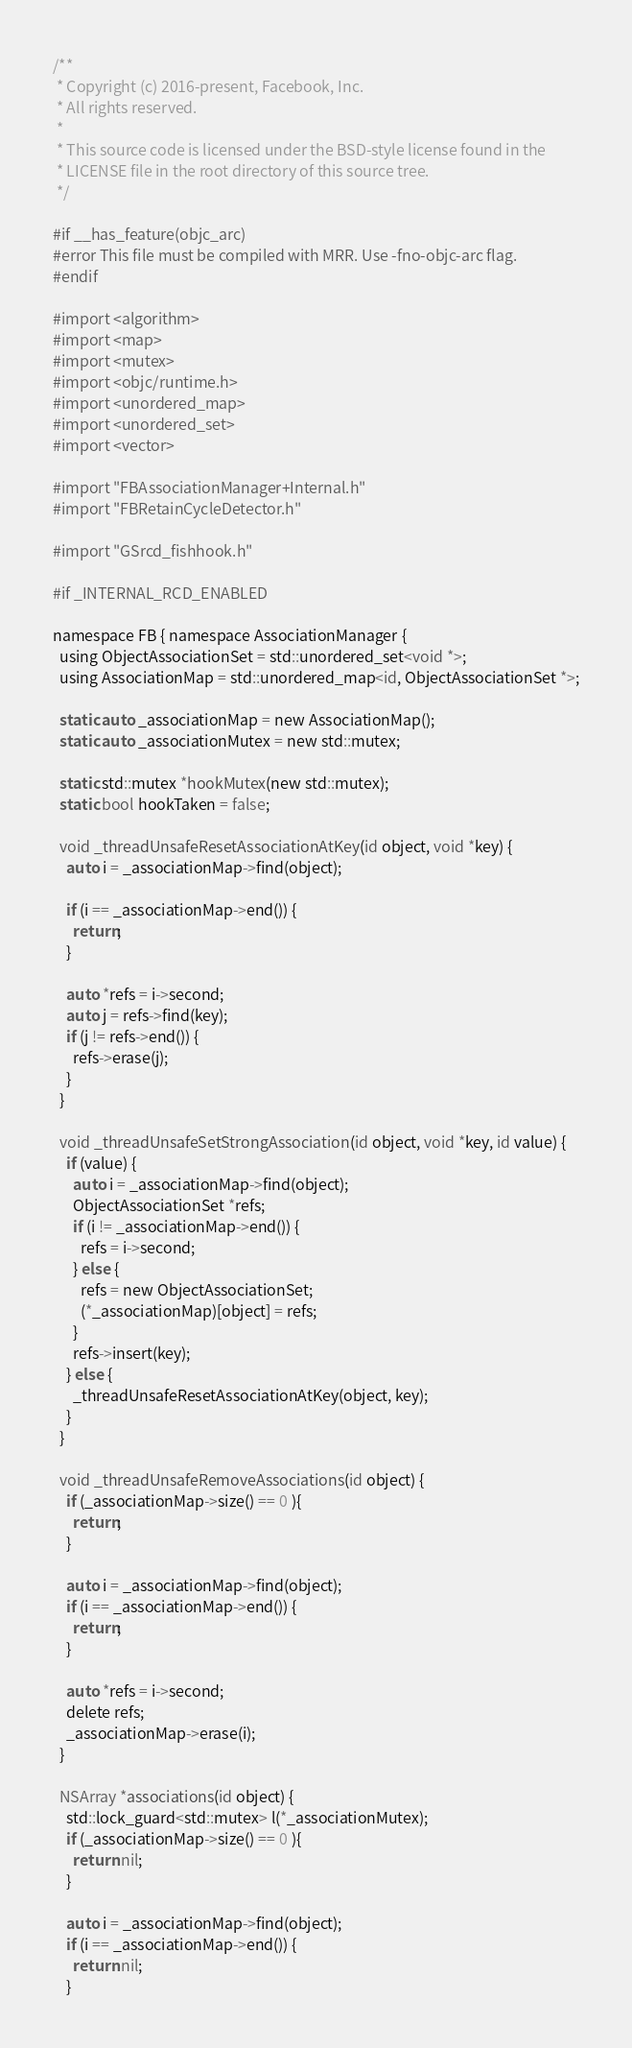<code> <loc_0><loc_0><loc_500><loc_500><_ObjectiveC_>/**
 * Copyright (c) 2016-present, Facebook, Inc.
 * All rights reserved.
 *
 * This source code is licensed under the BSD-style license found in the
 * LICENSE file in the root directory of this source tree.
 */

#if __has_feature(objc_arc)
#error This file must be compiled with MRR. Use -fno-objc-arc flag.
#endif

#import <algorithm>
#import <map>
#import <mutex>
#import <objc/runtime.h>
#import <unordered_map>
#import <unordered_set>
#import <vector>

#import "FBAssociationManager+Internal.h"
#import "FBRetainCycleDetector.h"

#import "GSrcd_fishhook.h"

#if _INTERNAL_RCD_ENABLED

namespace FB { namespace AssociationManager {
  using ObjectAssociationSet = std::unordered_set<void *>;
  using AssociationMap = std::unordered_map<id, ObjectAssociationSet *>;

  static auto _associationMap = new AssociationMap();
  static auto _associationMutex = new std::mutex;

  static std::mutex *hookMutex(new std::mutex);
  static bool hookTaken = false;

  void _threadUnsafeResetAssociationAtKey(id object, void *key) {
    auto i = _associationMap->find(object);

    if (i == _associationMap->end()) {
      return;
    }

    auto *refs = i->second;
    auto j = refs->find(key);
    if (j != refs->end()) {
      refs->erase(j);
    }
  }

  void _threadUnsafeSetStrongAssociation(id object, void *key, id value) {
    if (value) {
      auto i = _associationMap->find(object);
      ObjectAssociationSet *refs;
      if (i != _associationMap->end()) {
        refs = i->second;
      } else {
        refs = new ObjectAssociationSet;
        (*_associationMap)[object] = refs;
      }
      refs->insert(key);
    } else {
      _threadUnsafeResetAssociationAtKey(object, key);
    }
  }

  void _threadUnsafeRemoveAssociations(id object) {
    if (_associationMap->size() == 0 ){
      return;
    }

    auto i = _associationMap->find(object);
    if (i == _associationMap->end()) {
      return;
    }

    auto *refs = i->second;
    delete refs;
    _associationMap->erase(i);
  }

  NSArray *associations(id object) {
    std::lock_guard<std::mutex> l(*_associationMutex);
    if (_associationMap->size() == 0 ){
      return nil;
    }

    auto i = _associationMap->find(object);
    if (i == _associationMap->end()) {
      return nil;
    }
</code> 